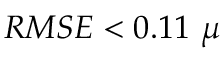Convert formula to latex. <formula><loc_0><loc_0><loc_500><loc_500>R M S E < 0 . 1 1 \mu</formula> 